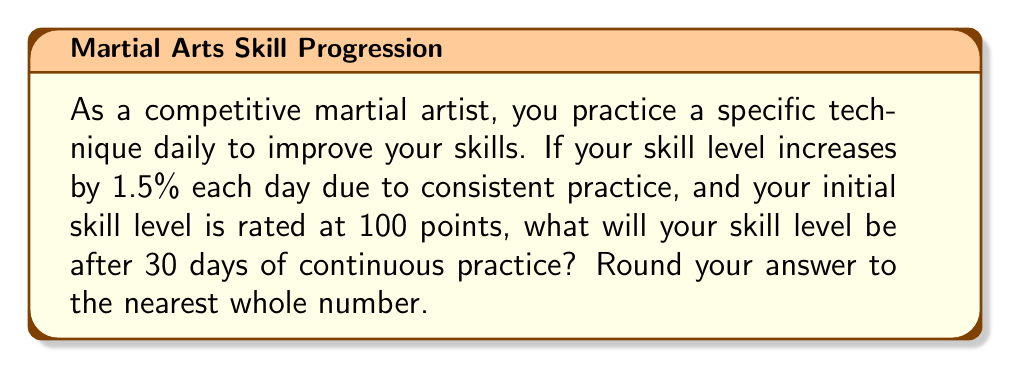Help me with this question. To solve this problem, we need to use the compound interest formula, which is similar to the compound effect of daily practice:

$$ A = P(1 + r)^n $$

Where:
$A$ = Final skill level
$P$ = Initial skill level
$r$ = Daily improvement rate (as a decimal)
$n$ = Number of days

Given:
$P = 100$ (initial skill level)
$r = 0.015$ (1.5% daily improvement)
$n = 30$ days

Let's substitute these values into the formula:

$$ A = 100(1 + 0.015)^{30} $$

Now, let's calculate:

$$ A = 100(1.015)^{30} $$
$$ A = 100 \times 1.563087... $$
$$ A = 156.3087... $$

Rounding to the nearest whole number:

$$ A \approx 156 $$
Answer: 156 points 